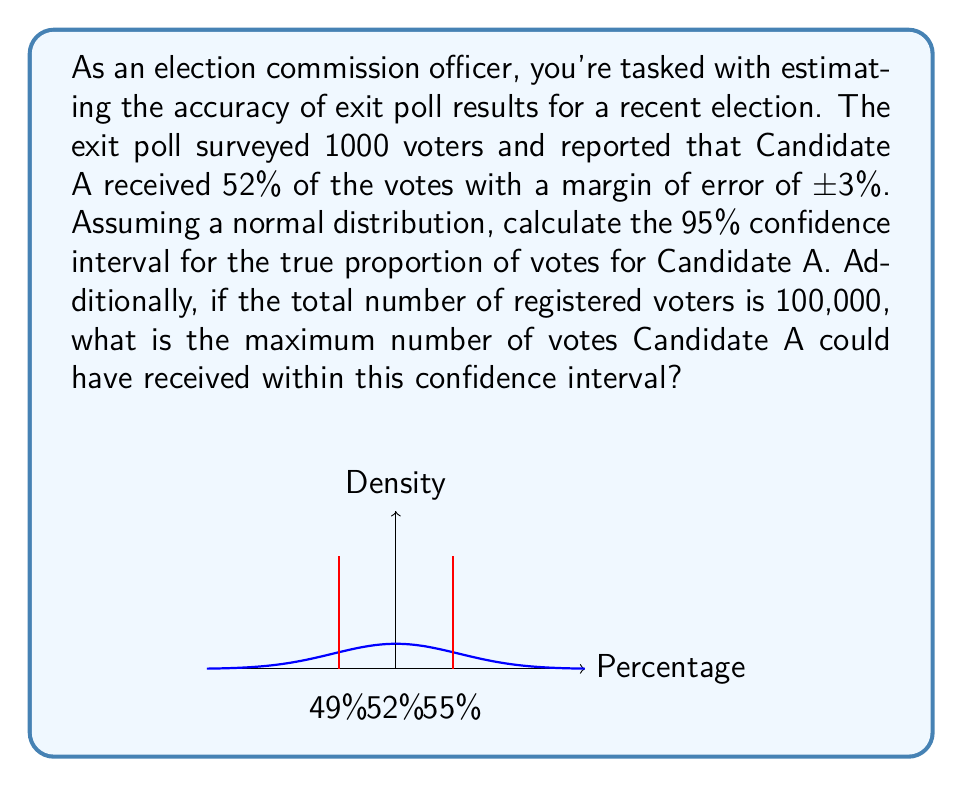Give your solution to this math problem. Let's approach this problem step-by-step:

1) The reported proportion is 52% (0.52) with a margin of error of 3% (0.03).

2) For a 95% confidence interval, we use a z-score of 1.96.

3) The formula for the confidence interval is:

   $$ p \pm z \cdot \sqrt{\frac{p(1-p)}{n}} $$

   where $p$ is the sample proportion, $z$ is the z-score, and $n$ is the sample size.

4) Plugging in our values:

   $$ 0.52 \pm 1.96 \cdot \sqrt{\frac{0.52(1-0.52)}{1000}} $$

5) Simplifying:

   $$ 0.52 \pm 1.96 \cdot \sqrt{\frac{0.2496}{1000}} = 0.52 \pm 1.96 \cdot 0.01578 $$

6) Calculating:

   $$ 0.52 \pm 0.0309 $$

7) Therefore, the 95% confidence interval is:

   $$ (0.4891, 0.5509) \text{ or } (48.91\%, 55.09\%) $$

8) For the maximum number of votes within this interval:
   - Total registered voters: 100,000
   - Upper bound of confidence interval: 55.09%

9) Maximum votes:

   $$ 100,000 \cdot 0.5509 = 55,090 $$
Answer: 95% CI: (48.91%, 55.09%); Max votes: 55,090 